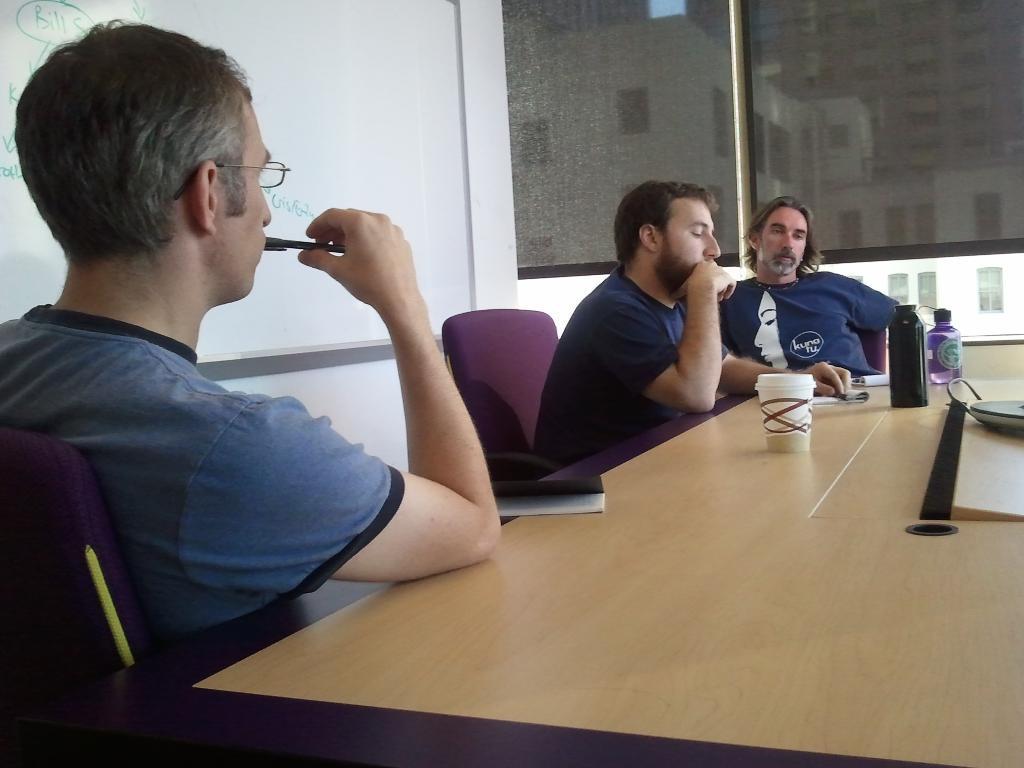Can you describe this image briefly? In this image I can see three men are sitting on chairs. Here on this table I can see few bottles and a cup. 